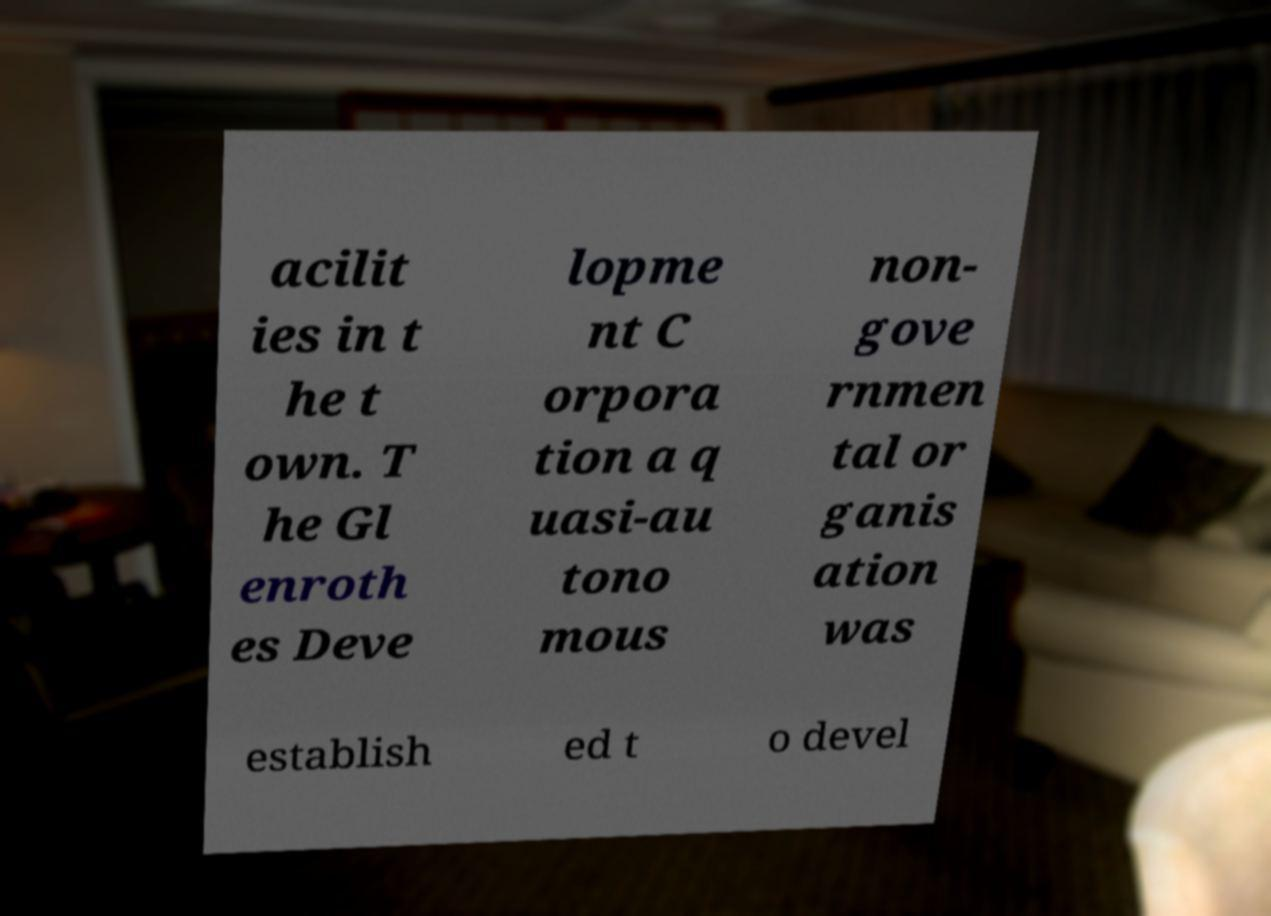Could you extract and type out the text from this image? acilit ies in t he t own. T he Gl enroth es Deve lopme nt C orpora tion a q uasi-au tono mous non- gove rnmen tal or ganis ation was establish ed t o devel 